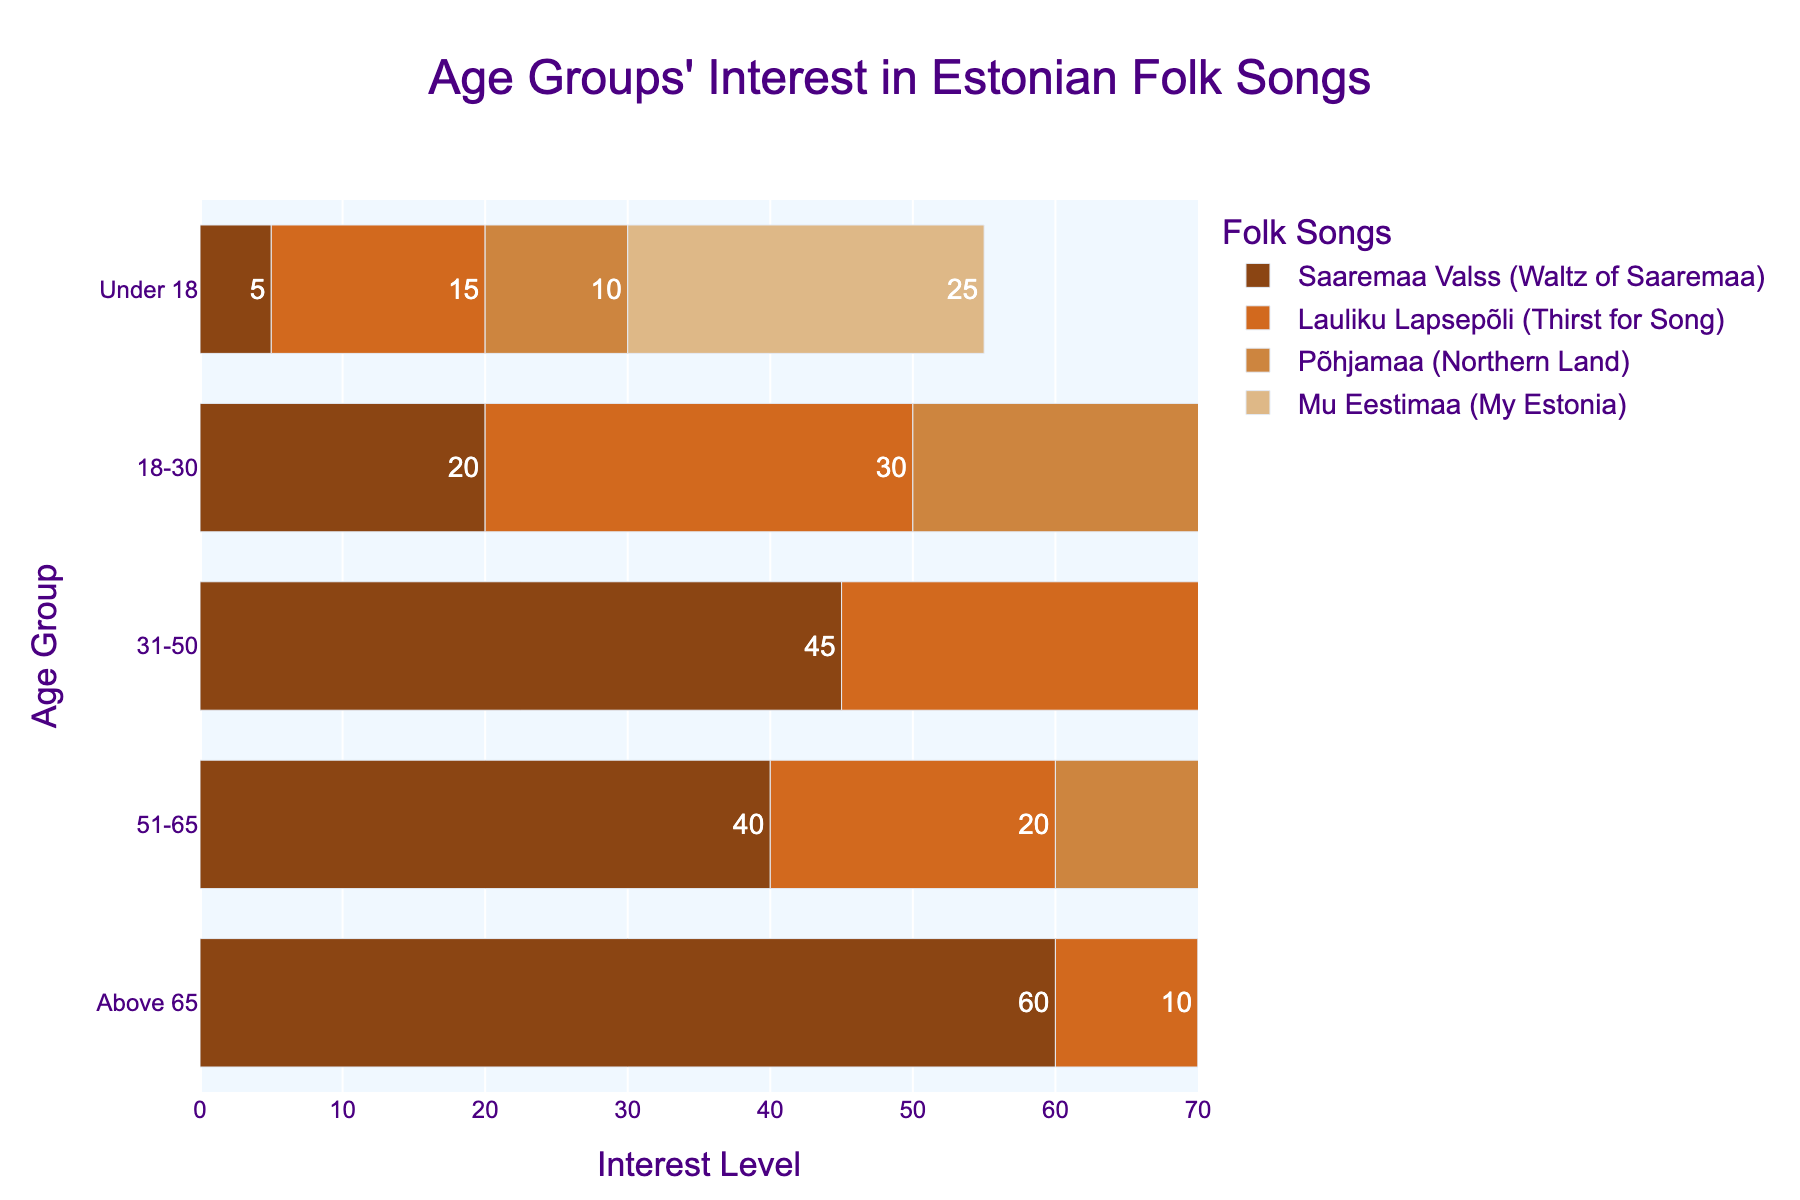Which age group shows the highest interest in "Lauliku Lapsepõli (Thirst for Song)"? For "Lauliku Lapsepõli (Thirst for Song)", look for the age group with the longest bar. The age group 31-50 has the longest bar under this song.
Answer: 31-50 Which song has the highest average interest across all age groups? Sum the interest levels of each song and divide by the number of age groups (5). "Saaremaa Valss (Waltz of Saaremaa)" has totals of (5 + 20 + 45 + 40 + 60) / 5 = 34, which is the highest.
Answer: Saaremaa Valss (Waltz of Saaremaa) Which age group has equal interest in both "Põhjamaa (Northern Land)" and "Mu Eestimaa (My Estonia)"? Check the interest levels for each age group across these two songs. For the Under 18 group, Põhjamaa = 10 and Mu Eestimaa = 25, these values are different. The opposite is true for other age groups except 51-65 with Põhjamaa = 15 and Mu Eestimaa = 15, these values being equal.
Answer: 51-65 What is the difference in interest levels between "Lauliku Lapsepõli (Thirst for Song)" and "Saaremaa Valss (Waltz of Saaremaa)" for the Above 65 age group? For Above 65, subtract the interest of "Lauliku Lapsepõli" (10) from "Saaremaa Valss" (60): 60 - 10 = 50.
Answer: 50 Which song does the age group 18-30 show more interest in, "Põhjamaa (Northern Land)" or "Mu Eestimaa (My Estonia)"? For the age group 18-30, compare bars for "Põhjamaa" (40) and "Mu Eestimaa" (35). "Põhjamaa has a higher value.
Answer: Põhjamaa (Northern Land) What is the average interest level in "Mu Eestimaa (My Estonia)" for all age groups? Calculate the sum of interest levels and divide by the number of age groups: (25 + 35 + 30 + 15 + 5) / 5 = 22.
Answer: 22 